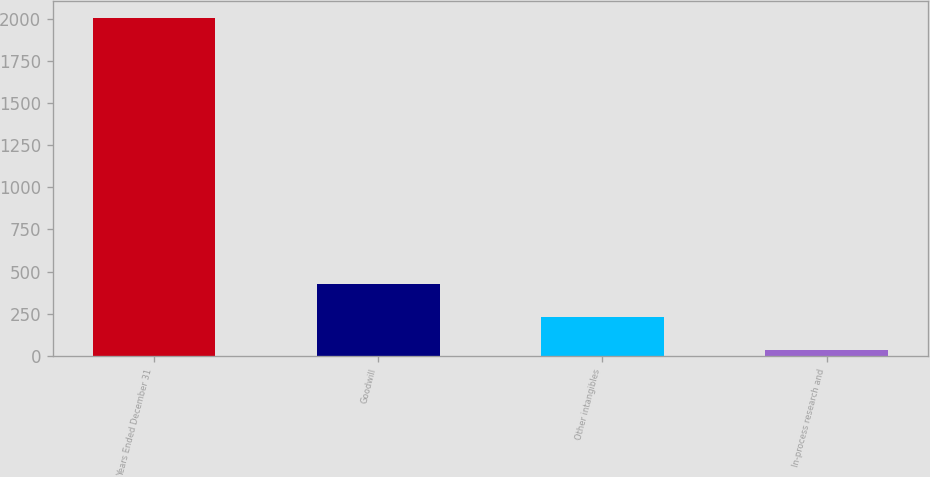Convert chart to OTSL. <chart><loc_0><loc_0><loc_500><loc_500><bar_chart><fcel>Years Ended December 31<fcel>Goodwill<fcel>Other intangibles<fcel>In-process research and<nl><fcel>2003<fcel>426.2<fcel>229.1<fcel>32<nl></chart> 